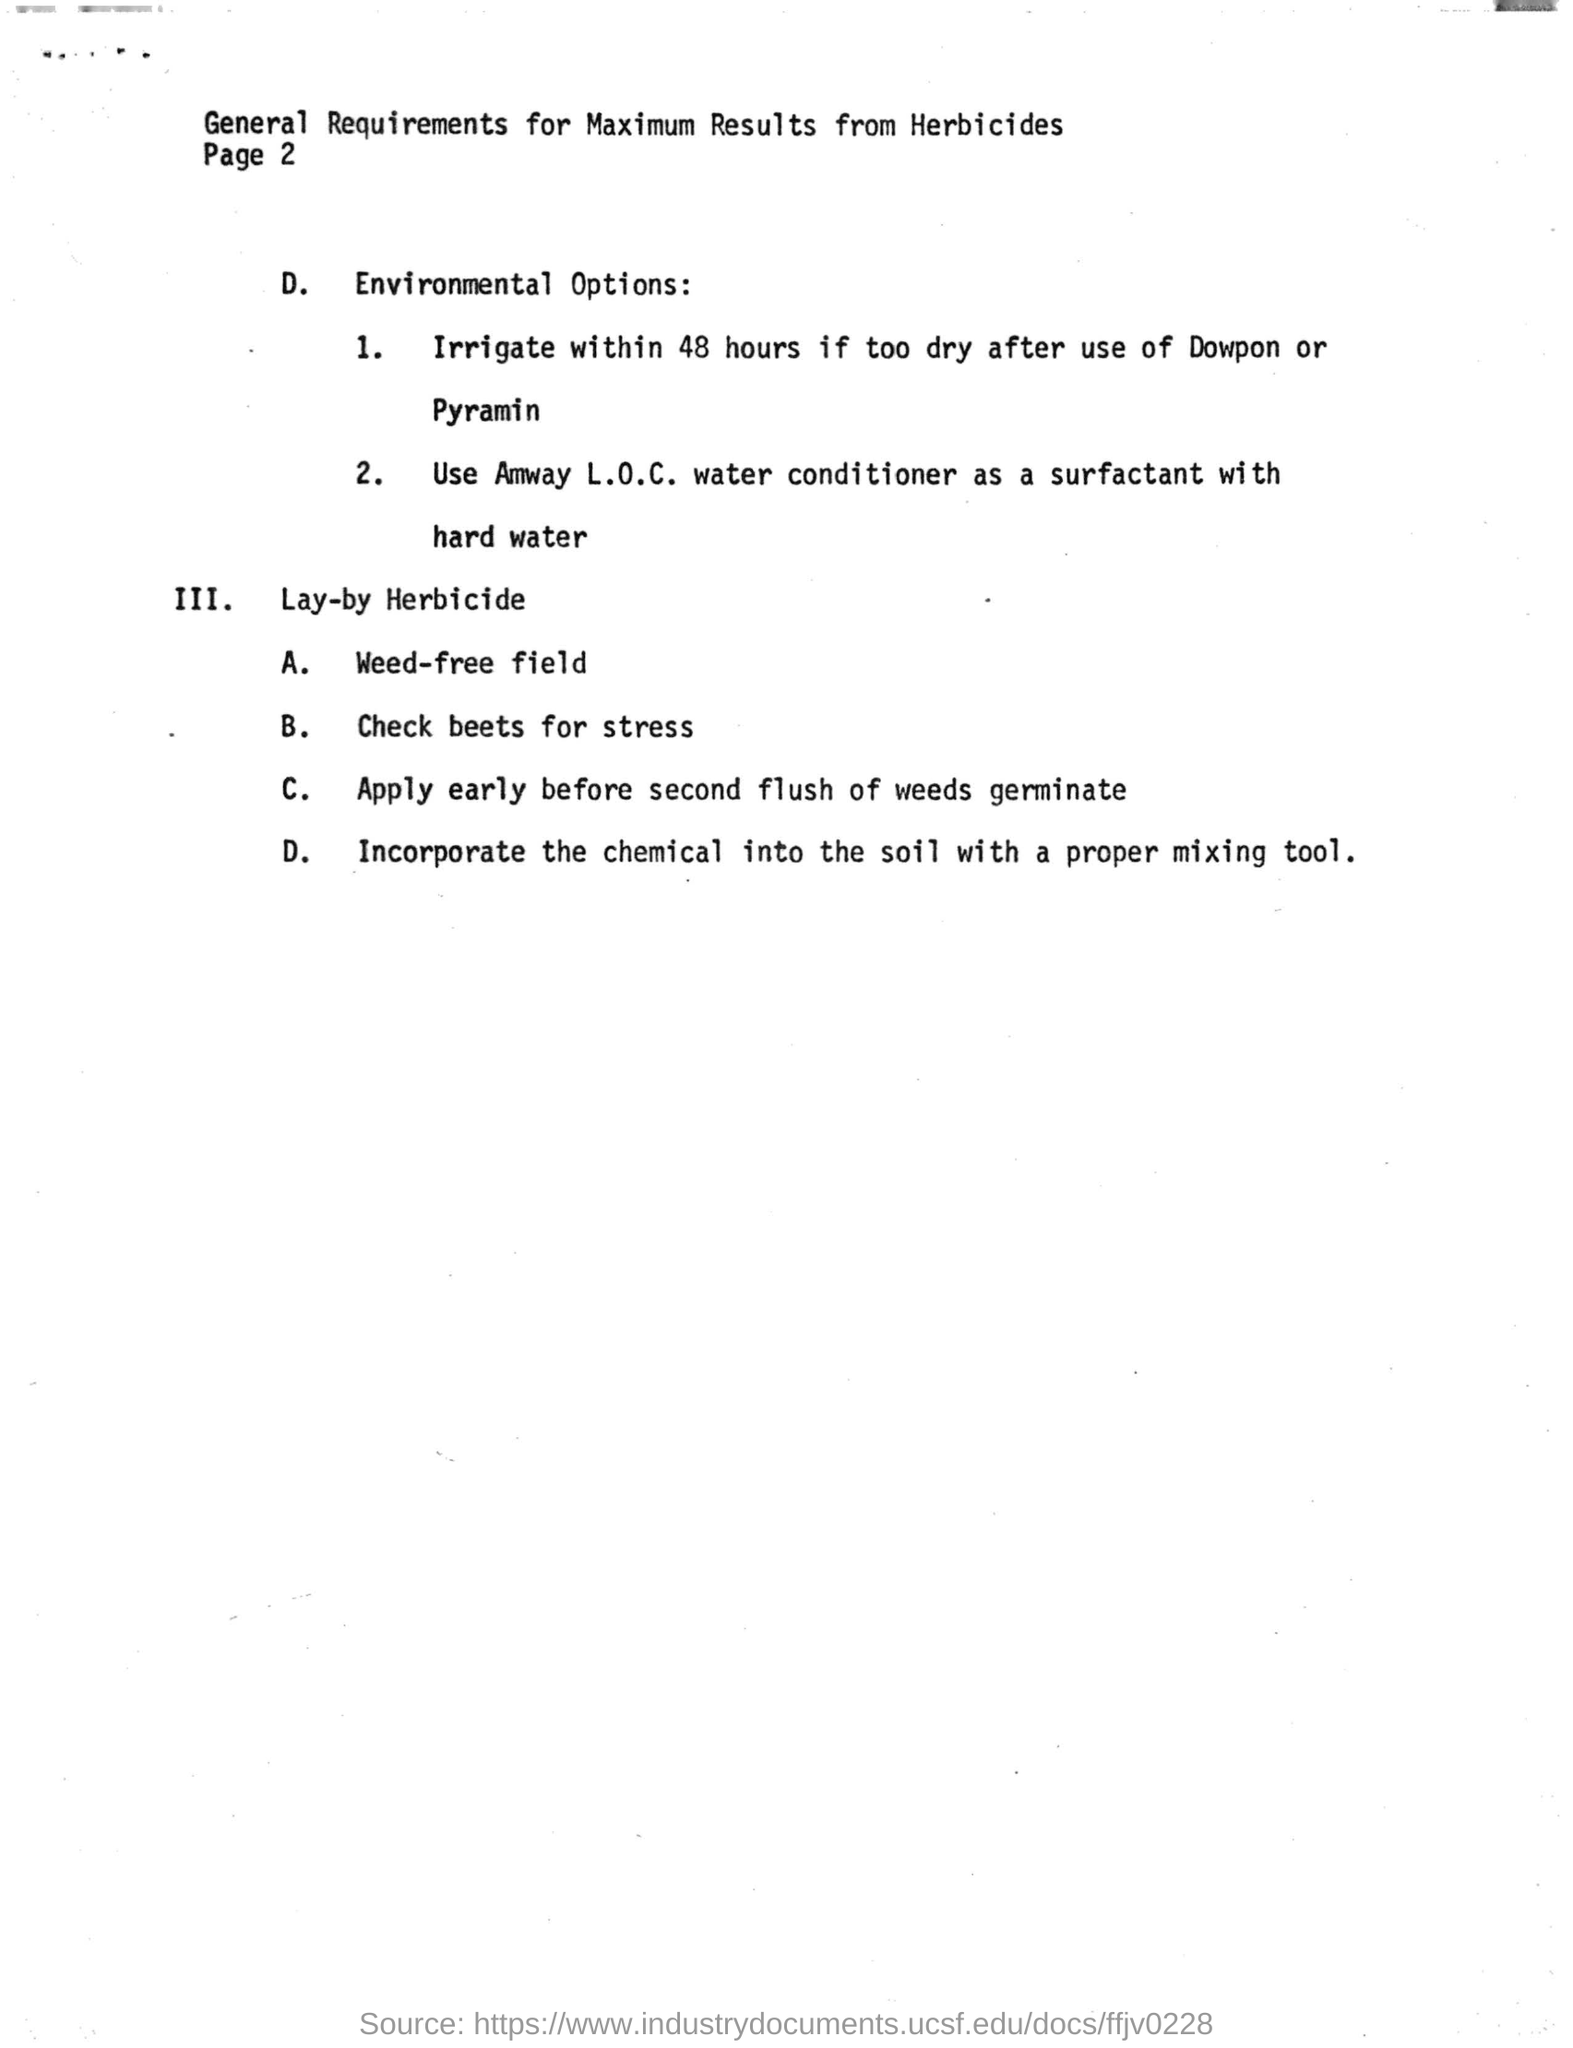Give some essential details in this illustration. I'm sorry, but I'm not sure what you are referring to. Could you please provide more context or information so I can better understand your request? Amway L.O.C product uses a water conditioner as a surfactant in hard water. 